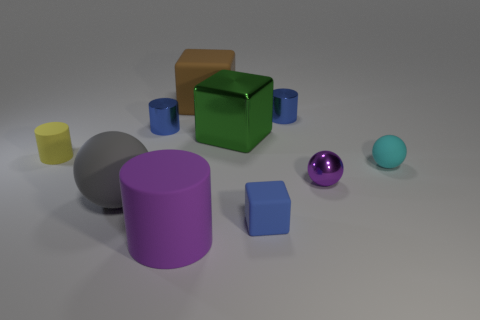Subtract all yellow cylinders. How many cylinders are left? 3 Subtract 2 cylinders. How many cylinders are left? 2 Subtract all purple cylinders. How many cylinders are left? 3 Subtract all blocks. How many objects are left? 7 Add 5 small blue matte cubes. How many small blue matte cubes exist? 6 Subtract 1 blue blocks. How many objects are left? 9 Subtract all green blocks. Subtract all brown cylinders. How many blocks are left? 2 Subtract all green blocks. How many blue cylinders are left? 2 Subtract all large objects. Subtract all tiny yellow matte blocks. How many objects are left? 6 Add 1 brown matte things. How many brown matte things are left? 2 